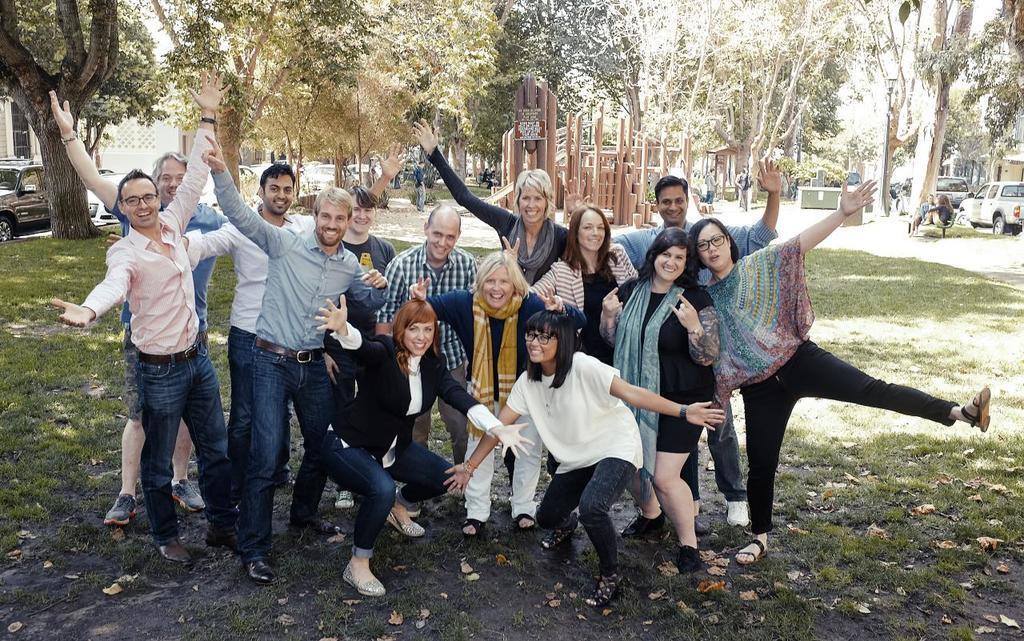Can you describe this image briefly? In this image we can see a group of people. There is a grassy land in the image. There are many dry leaves on the ground. There are many buildings in the image. There are many trees in the image. There are many vehicles at the either sides of the image. 